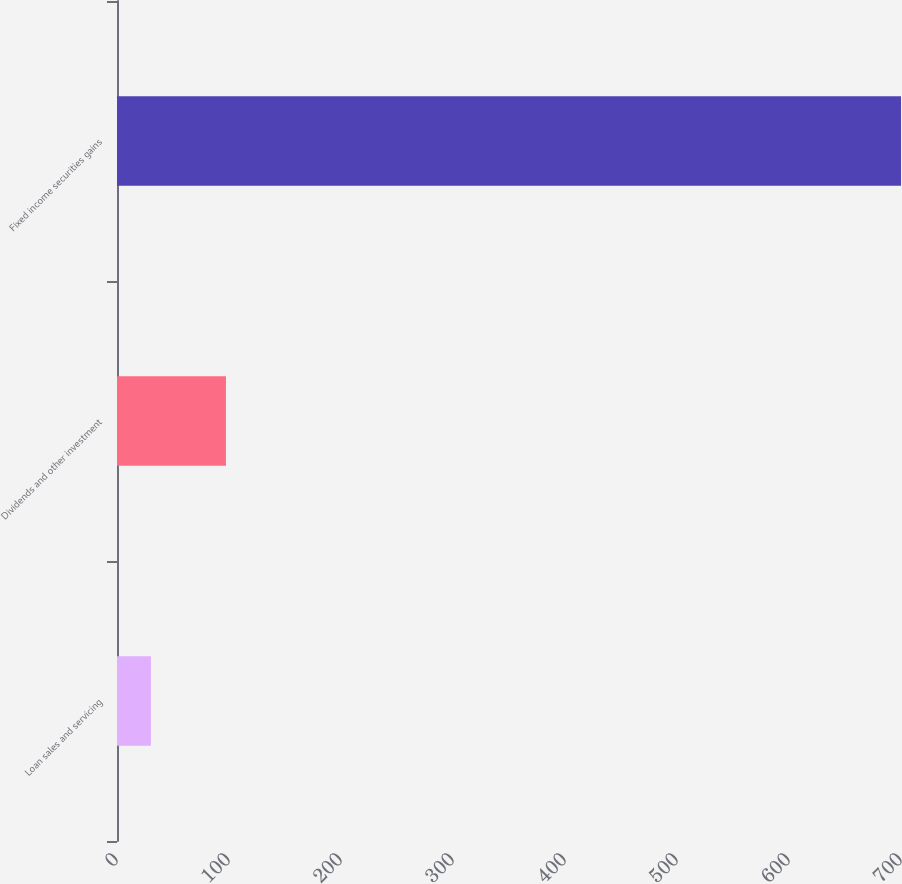Convert chart to OTSL. <chart><loc_0><loc_0><loc_500><loc_500><bar_chart><fcel>Loan sales and servicing<fcel>Dividends and other investment<fcel>Fixed income securities gains<nl><fcel>30.3<fcel>97.27<fcel>700<nl></chart> 